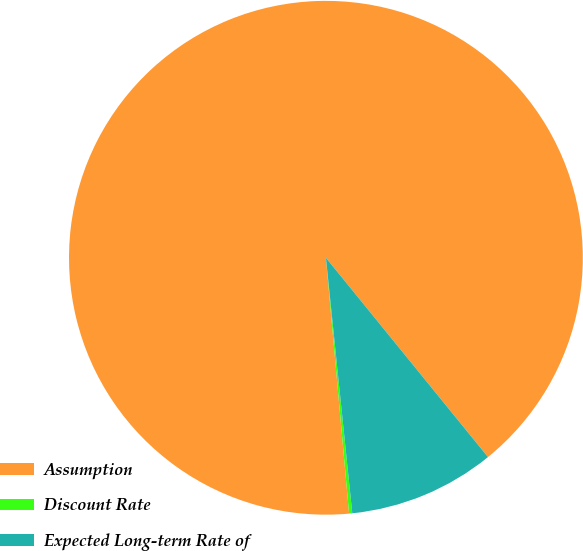Convert chart. <chart><loc_0><loc_0><loc_500><loc_500><pie_chart><fcel>Assumption<fcel>Discount Rate<fcel>Expected Long-term Rate of<nl><fcel>90.57%<fcel>0.2%<fcel>9.23%<nl></chart> 